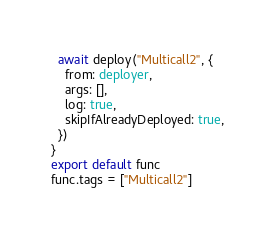Convert code to text. <code><loc_0><loc_0><loc_500><loc_500><_TypeScript_>  await deploy("Multicall2", {
    from: deployer,
    args: [],
    log: true,
    skipIfAlreadyDeployed: true,
  })
}
export default func
func.tags = ["Multicall2"]
</code> 